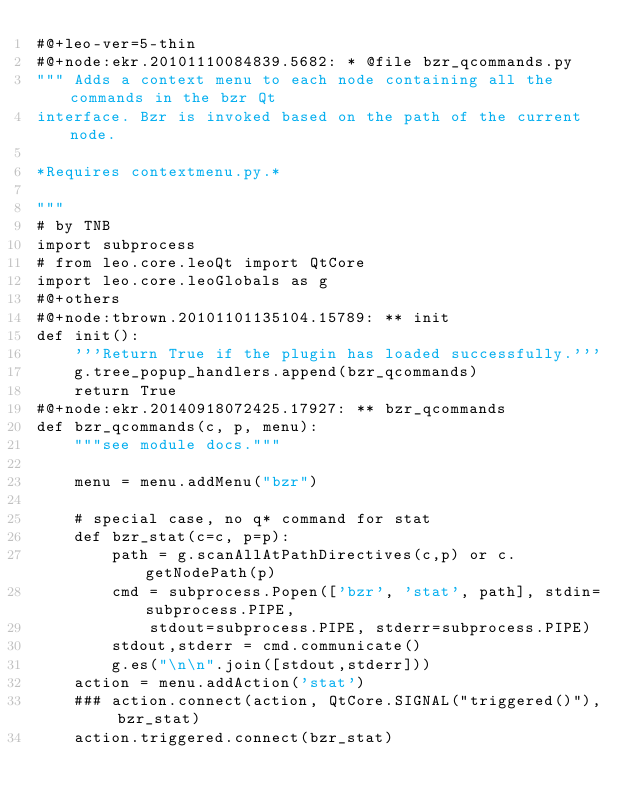<code> <loc_0><loc_0><loc_500><loc_500><_Python_>#@+leo-ver=5-thin
#@+node:ekr.20101110084839.5682: * @file bzr_qcommands.py
""" Adds a context menu to each node containing all the commands in the bzr Qt
interface. Bzr is invoked based on the path of the current node.

*Requires contextmenu.py.*

"""
# by TNB
import subprocess
# from leo.core.leoQt import QtCore
import leo.core.leoGlobals as g
#@+others
#@+node:tbrown.20101101135104.15789: ** init
def init():
    '''Return True if the plugin has loaded successfully.'''
    g.tree_popup_handlers.append(bzr_qcommands)
    return True
#@+node:ekr.20140918072425.17927: ** bzr_qcommands
def bzr_qcommands(c, p, menu):
    """see module docs."""

    menu = menu.addMenu("bzr")

    # special case, no q* command for stat
    def bzr_stat(c=c, p=p):
        path = g.scanAllAtPathDirectives(c,p) or c.getNodePath(p)
        cmd = subprocess.Popen(['bzr', 'stat', path], stdin=subprocess.PIPE,
            stdout=subprocess.PIPE, stderr=subprocess.PIPE)
        stdout,stderr = cmd.communicate()
        g.es("\n\n".join([stdout,stderr]))
    action = menu.addAction('stat')
    ### action.connect(action, QtCore.SIGNAL("triggered()"), bzr_stat)
    action.triggered.connect(bzr_stat)
</code> 